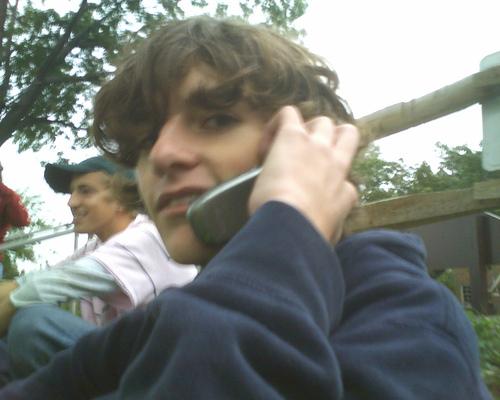Is the face of the cell phone that is touching the face predominantly metal or glass?
Answer briefly. Metal. What color is the undershirt of the man in the hat?
Quick response, please. Gray. Which technology is there in her hand?
Write a very short answer. Cell phone. 